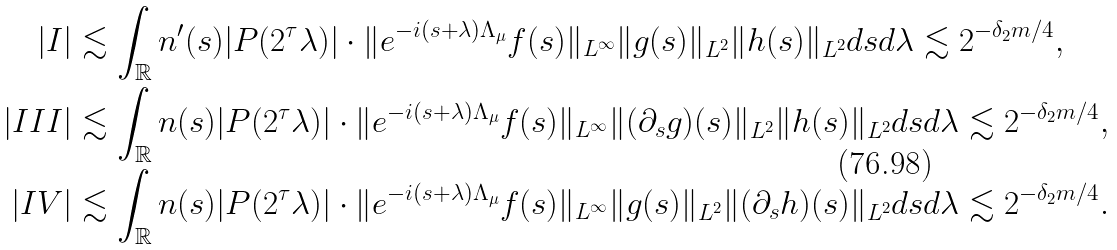Convert formula to latex. <formula><loc_0><loc_0><loc_500><loc_500>\left | I \right | & \lesssim \int _ { \mathbb { R } } n ^ { \prime } ( s ) | P ( 2 ^ { \tau } \lambda ) | \cdot \| e ^ { - i ( s + \lambda ) \Lambda _ { \mu } } f ( s ) \| _ { L ^ { \infty } } \| g ( s ) \| _ { L ^ { 2 } } \| h ( s ) \| _ { L ^ { 2 } } d s d \lambda \lesssim 2 ^ { - \delta _ { 2 } m / 4 } , \\ \left | I I I \right | & \lesssim \int _ { \mathbb { R } } n ( s ) | P ( 2 ^ { \tau } \lambda ) | \cdot \| e ^ { - i ( s + \lambda ) \Lambda _ { \mu } } f ( s ) \| _ { L ^ { \infty } } \| ( \partial _ { s } g ) ( s ) \| _ { L ^ { 2 } } \| h ( s ) \| _ { L ^ { 2 } } d s d \lambda \lesssim 2 ^ { - \delta _ { 2 } m / 4 } , \\ \left | I V \right | & \lesssim \int _ { \mathbb { R } } n ( s ) | P ( 2 ^ { \tau } \lambda ) | \cdot \| e ^ { - i ( s + \lambda ) \Lambda _ { \mu } } f ( s ) \| _ { L ^ { \infty } } \| g ( s ) \| _ { L ^ { 2 } } \| ( \partial _ { s } h ) ( s ) \| _ { L ^ { 2 } } d s d \lambda \lesssim 2 ^ { - \delta _ { 2 } m / 4 } .</formula> 